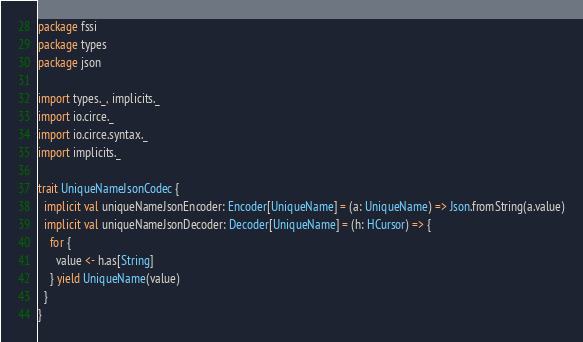<code> <loc_0><loc_0><loc_500><loc_500><_Scala_>package fssi
package types
package json

import types._, implicits._
import io.circe._
import io.circe.syntax._
import implicits._

trait UniqueNameJsonCodec {
  implicit val uniqueNameJsonEncoder: Encoder[UniqueName] = (a: UniqueName) => Json.fromString(a.value)
  implicit val uniqueNameJsonDecoder: Decoder[UniqueName] = (h: HCursor) => {
    for {
      value <- h.as[String]
    } yield UniqueName(value)
  }
}
</code> 